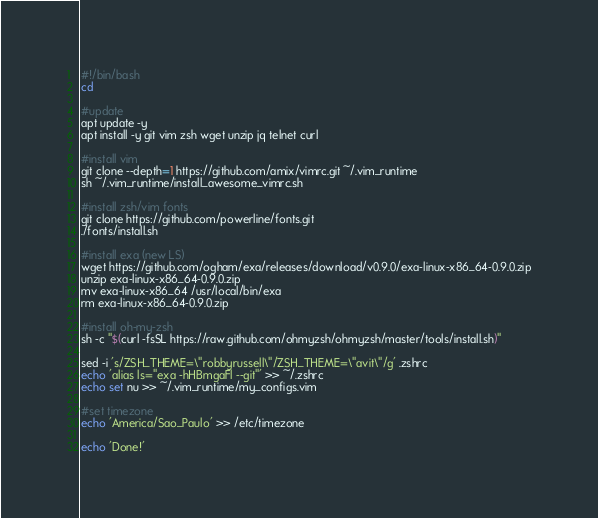Convert code to text. <code><loc_0><loc_0><loc_500><loc_500><_Bash_>#!/bin/bash
cd

#update
apt update -y
apt install -y git vim zsh wget unzip jq telnet curl

#install vim
git clone --depth=1 https://github.com/amix/vimrc.git ~/.vim_runtime
sh ~/.vim_runtime/install_awesome_vimrc.sh

#install zsh/vim fonts
git clone https://github.com/powerline/fonts.git
./fonts/install.sh

#install exa (new LS)
wget https://github.com/ogham/exa/releases/download/v0.9.0/exa-linux-x86_64-0.9.0.zip
unzip exa-linux-x86_64-0.9.0.zip
mv exa-linux-x86_64 /usr/local/bin/exa
rm exa-linux-x86_64-0.9.0.zip

#install oh-my-zsh
sh -c "$(curl -fsSL https://raw.github.com/ohmyzsh/ohmyzsh/master/tools/install.sh)"

sed -i 's/ZSH_THEME=\"robbyrussell\"/ZSH_THEME=\"avit\"/g' .zshrc
echo 'alias ls="exa -hHBmgaFl --git"' >> ~/.zshrc
echo set nu >> ~/.vim_runtime/my_configs.vim

#set timezone
echo 'America/Sao_Paulo' >> /etc/timezone

echo 'Done!'
</code> 